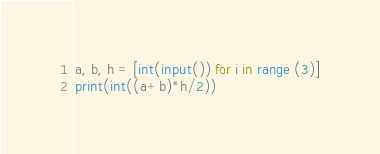<code> <loc_0><loc_0><loc_500><loc_500><_Python_>a, b, h = [int(input()) for i in range (3)]
print(int((a+b)*h/2))</code> 